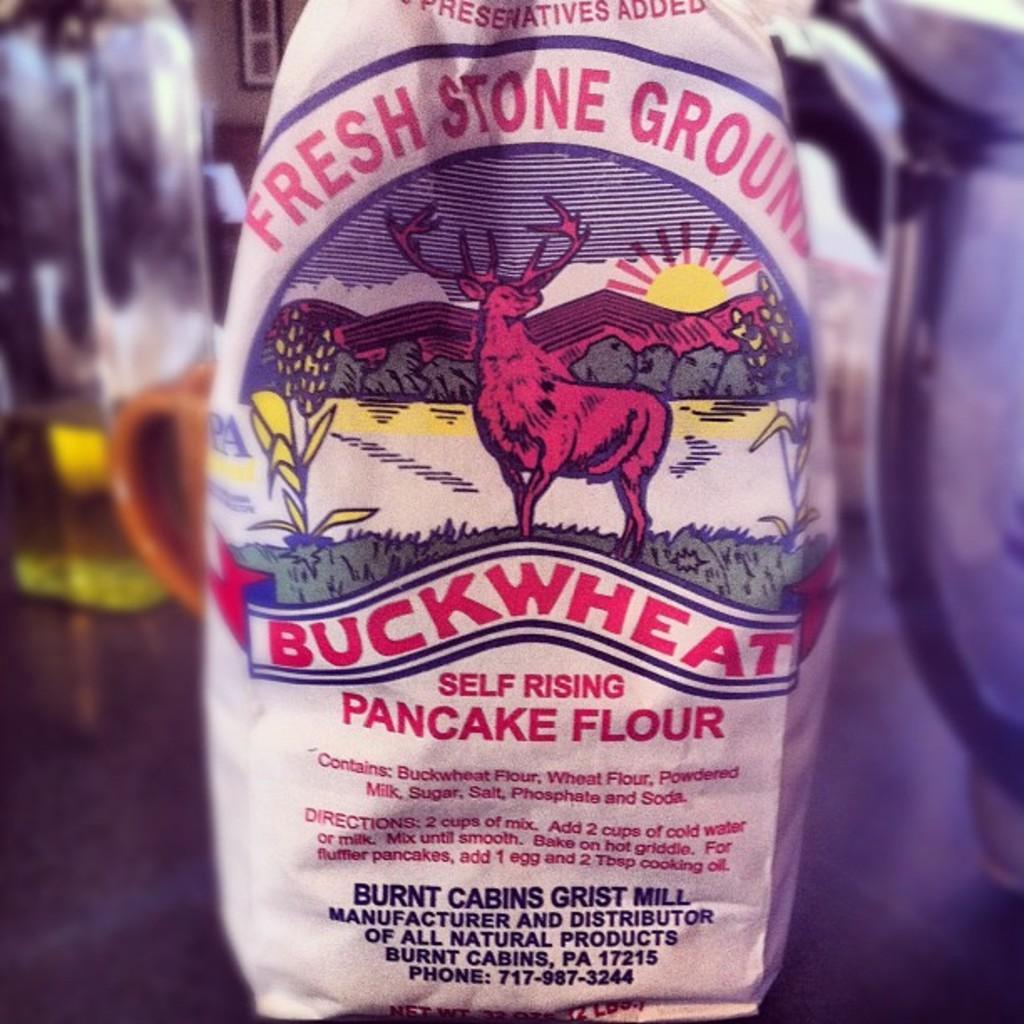How would you summarize this image in a sentence or two? In the center we can see bottle named as "Fresh Stone Ground". In the background there is wall,bottle and mug. 